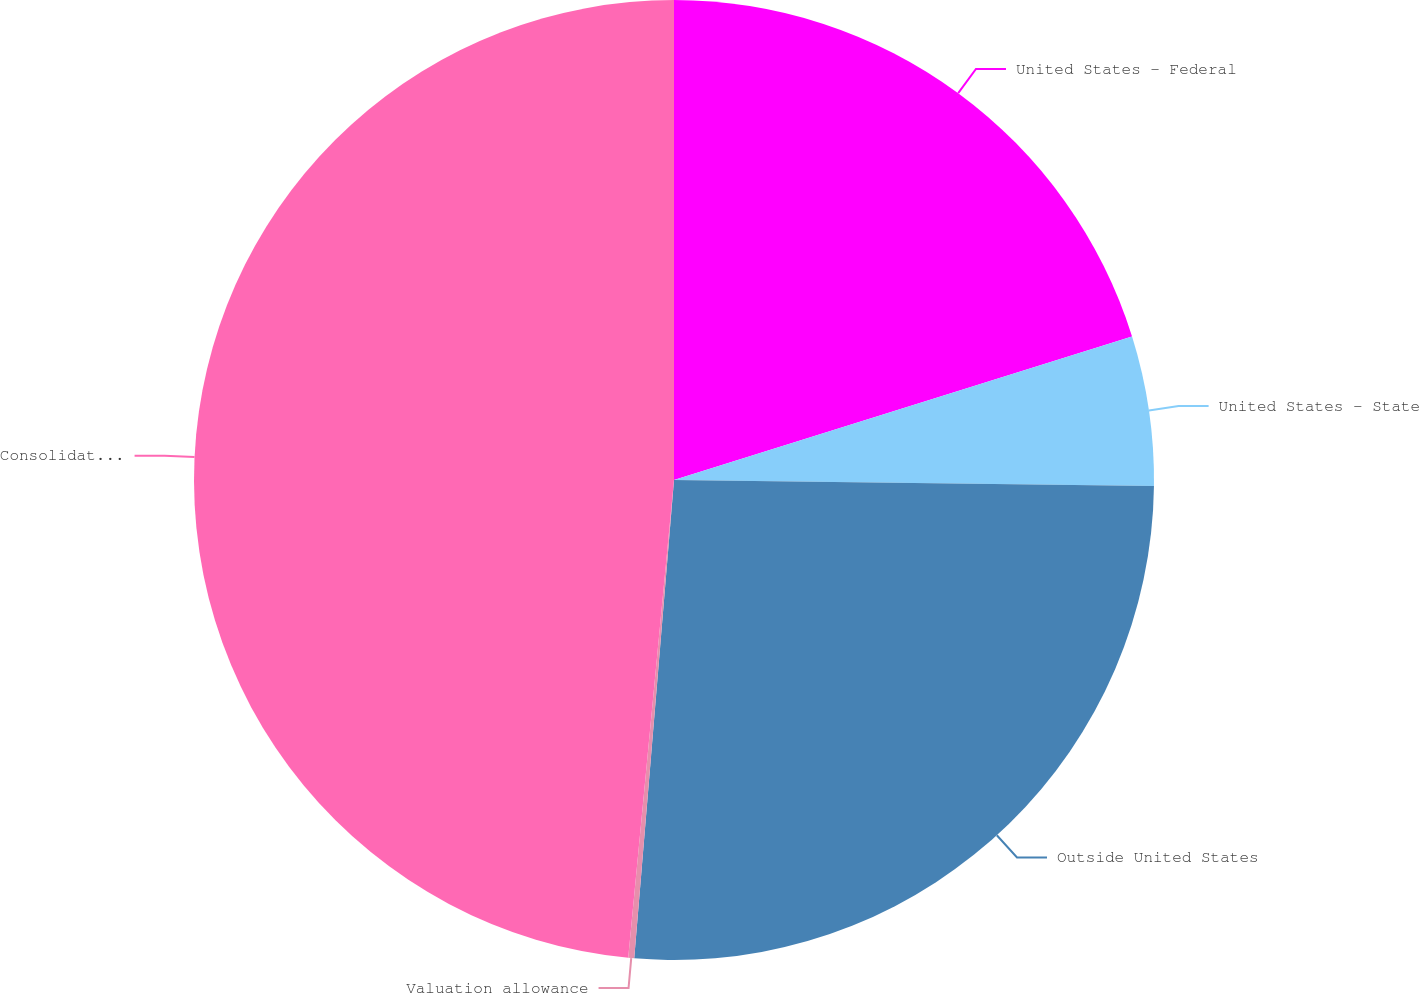Convert chart to OTSL. <chart><loc_0><loc_0><loc_500><loc_500><pie_chart><fcel>United States - Federal<fcel>United States - State<fcel>Outside United States<fcel>Valuation allowance<fcel>Consolidated taxes on income<nl><fcel>20.17%<fcel>5.03%<fcel>26.12%<fcel>0.2%<fcel>48.48%<nl></chart> 